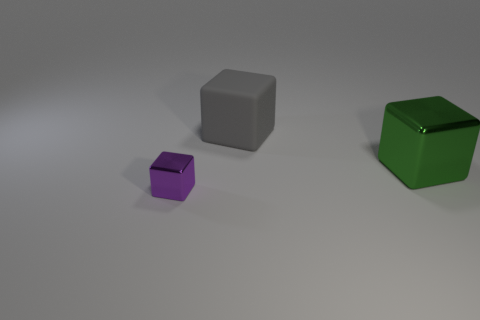Does the large green object have the same shape as the purple metal object? yes 